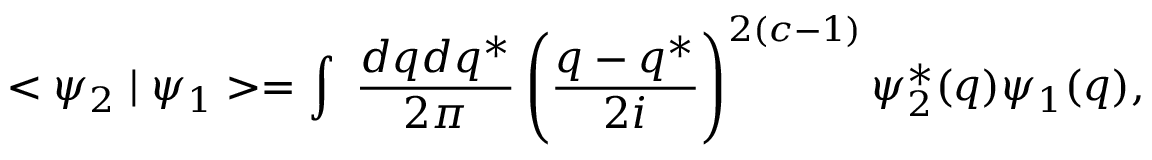Convert formula to latex. <formula><loc_0><loc_0><loc_500><loc_500>< \psi _ { 2 } | \psi _ { 1 } > = \int \, \frac { d q d q ^ { * } } { 2 \pi } \left ( \frac { q - q ^ { * } } { 2 i } \right ) ^ { 2 ( c - 1 ) } { \psi } _ { 2 } ^ { * } ( q ) \psi _ { 1 } ( q ) ,</formula> 